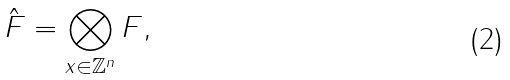Convert formula to latex. <formula><loc_0><loc_0><loc_500><loc_500>\hat { F } = \bigotimes _ { x \in \mathbb { Z } ^ { n } } F ,</formula> 